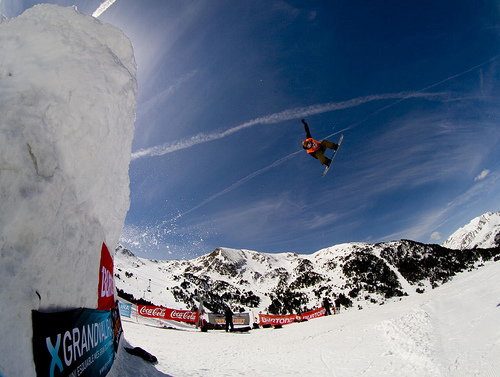Identify the text displayed in this image. CocaCola CocaCola XGRAND 